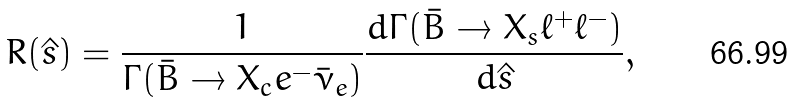<formula> <loc_0><loc_0><loc_500><loc_500>R ( \hat { s } ) = \frac { 1 } { \Gamma ( \bar { B } \to X _ { c } e ^ { - } \bar { \nu } _ { e } ) } \frac { d \Gamma ( \bar { B } \to X _ { s } \ell ^ { + } \ell ^ { - } ) } { d \hat { s } } ,</formula> 